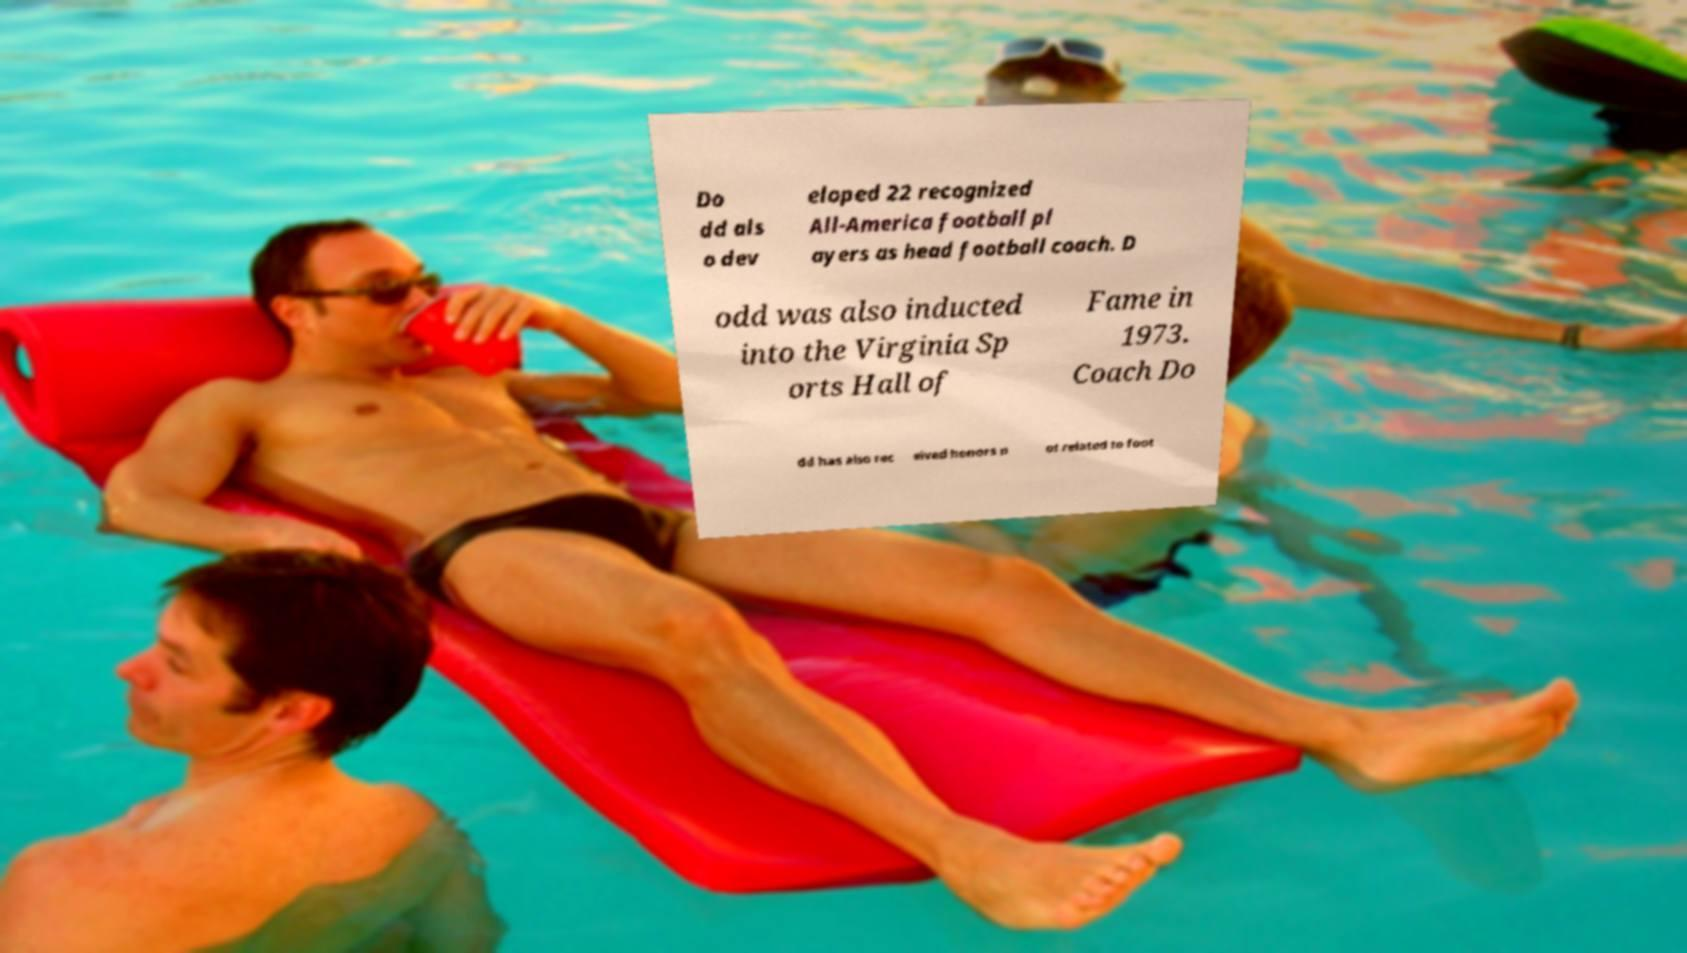Could you assist in decoding the text presented in this image and type it out clearly? Do dd als o dev eloped 22 recognized All-America football pl ayers as head football coach. D odd was also inducted into the Virginia Sp orts Hall of Fame in 1973. Coach Do dd has also rec eived honors n ot related to foot 